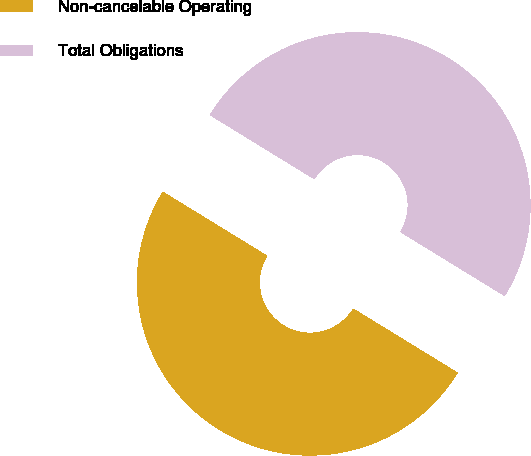Convert chart. <chart><loc_0><loc_0><loc_500><loc_500><pie_chart><fcel>Non-cancelable Operating<fcel>Total Obligations<nl><fcel>50.0%<fcel>50.0%<nl></chart> 